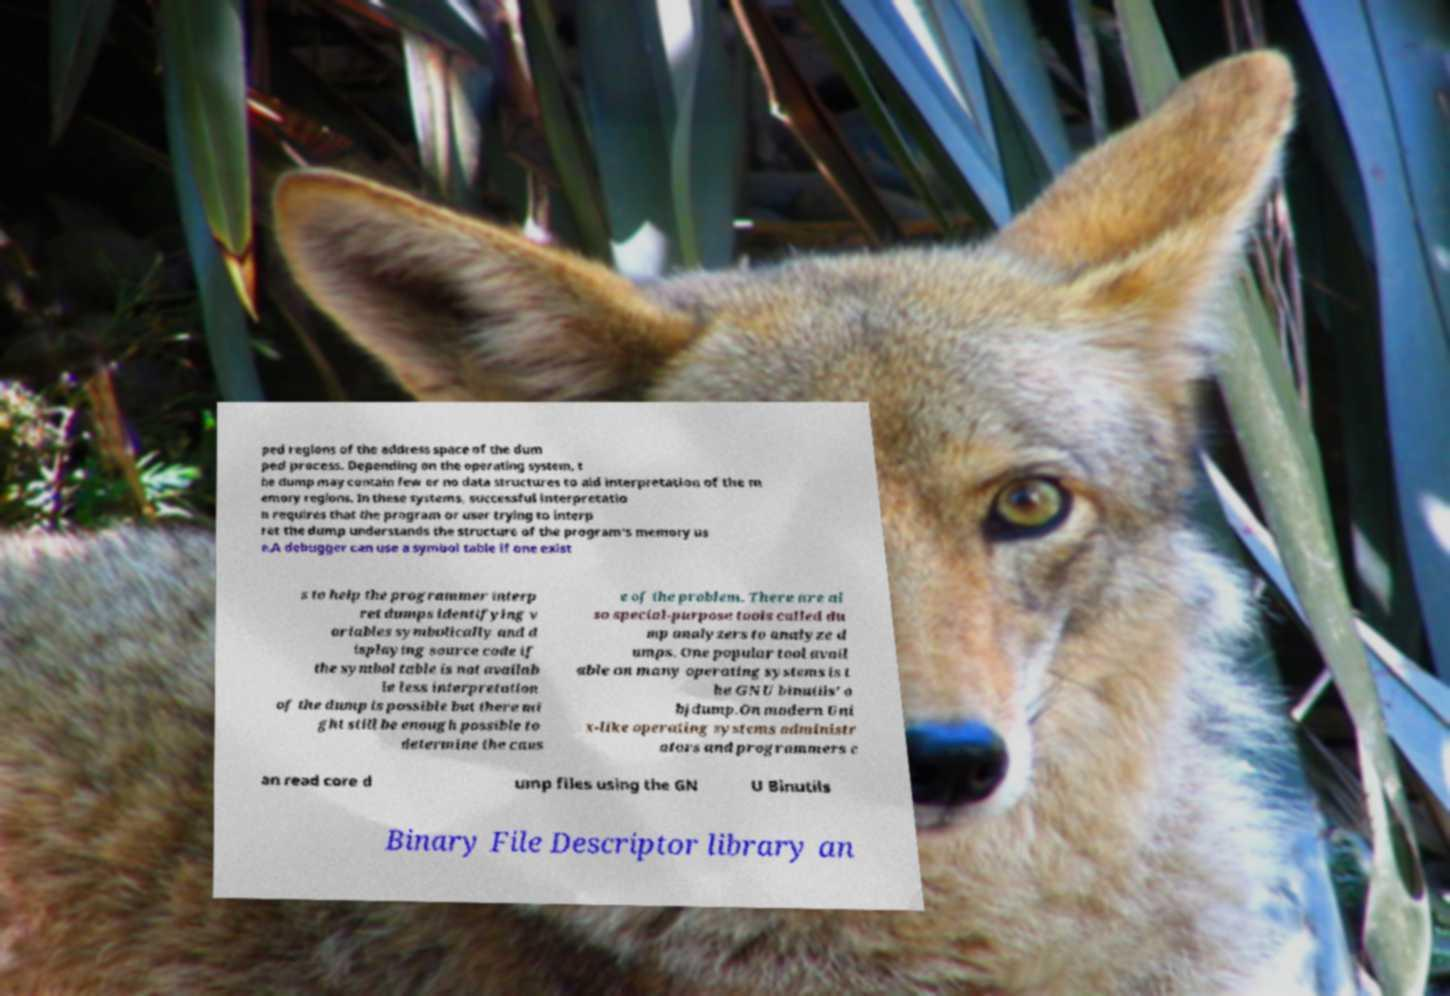Can you accurately transcribe the text from the provided image for me? ped regions of the address space of the dum ped process. Depending on the operating system, t he dump may contain few or no data structures to aid interpretation of the m emory regions. In these systems, successful interpretatio n requires that the program or user trying to interp ret the dump understands the structure of the program's memory us e.A debugger can use a symbol table if one exist s to help the programmer interp ret dumps identifying v ariables symbolically and d isplaying source code if the symbol table is not availab le less interpretation of the dump is possible but there mi ght still be enough possible to determine the caus e of the problem. There are al so special-purpose tools called du mp analyzers to analyze d umps. One popular tool avail able on many operating systems is t he GNU binutils' o bjdump.On modern Uni x-like operating systems administr ators and programmers c an read core d ump files using the GN U Binutils Binary File Descriptor library an 